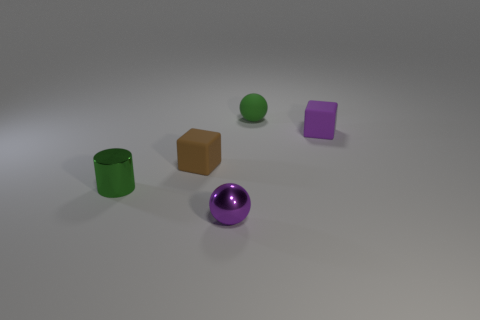Add 2 brown matte blocks. How many objects exist? 7 Subtract all spheres. How many objects are left? 3 Subtract 0 gray cubes. How many objects are left? 5 Subtract all green shiny cylinders. Subtract all small matte objects. How many objects are left? 1 Add 2 spheres. How many spheres are left? 4 Add 1 small cylinders. How many small cylinders exist? 2 